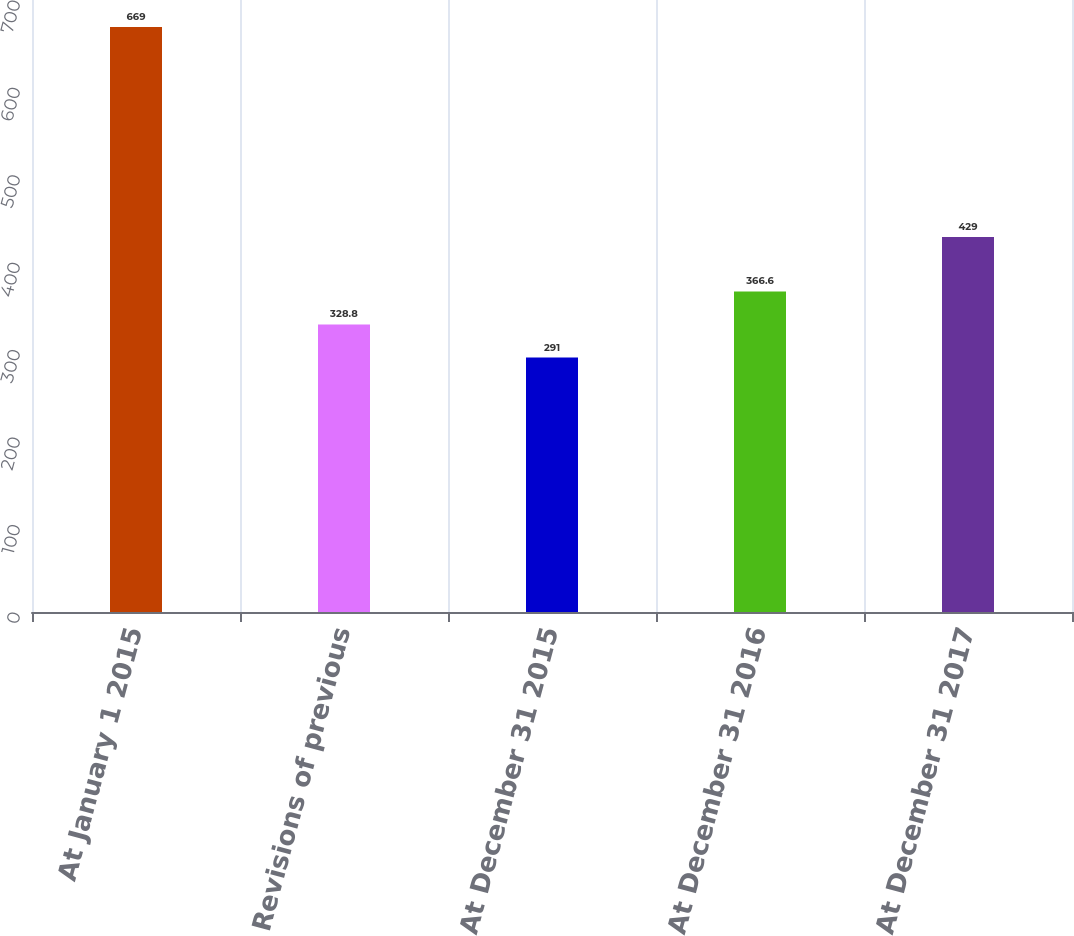<chart> <loc_0><loc_0><loc_500><loc_500><bar_chart><fcel>At January 1 2015<fcel>Revisions of previous<fcel>At December 31 2015<fcel>At December 31 2016<fcel>At December 31 2017<nl><fcel>669<fcel>328.8<fcel>291<fcel>366.6<fcel>429<nl></chart> 